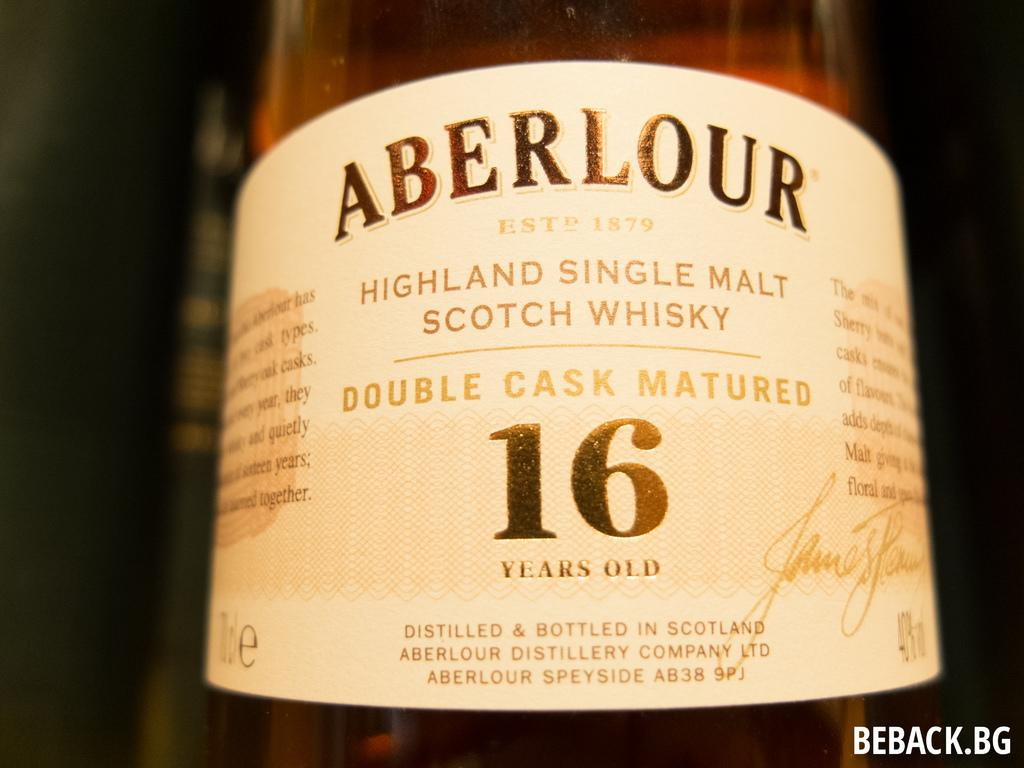<image>
Create a compact narrative representing the image presented. The 16 years old Highland single malt Scotch Whisky was produced by Aberlour, established 1879. 